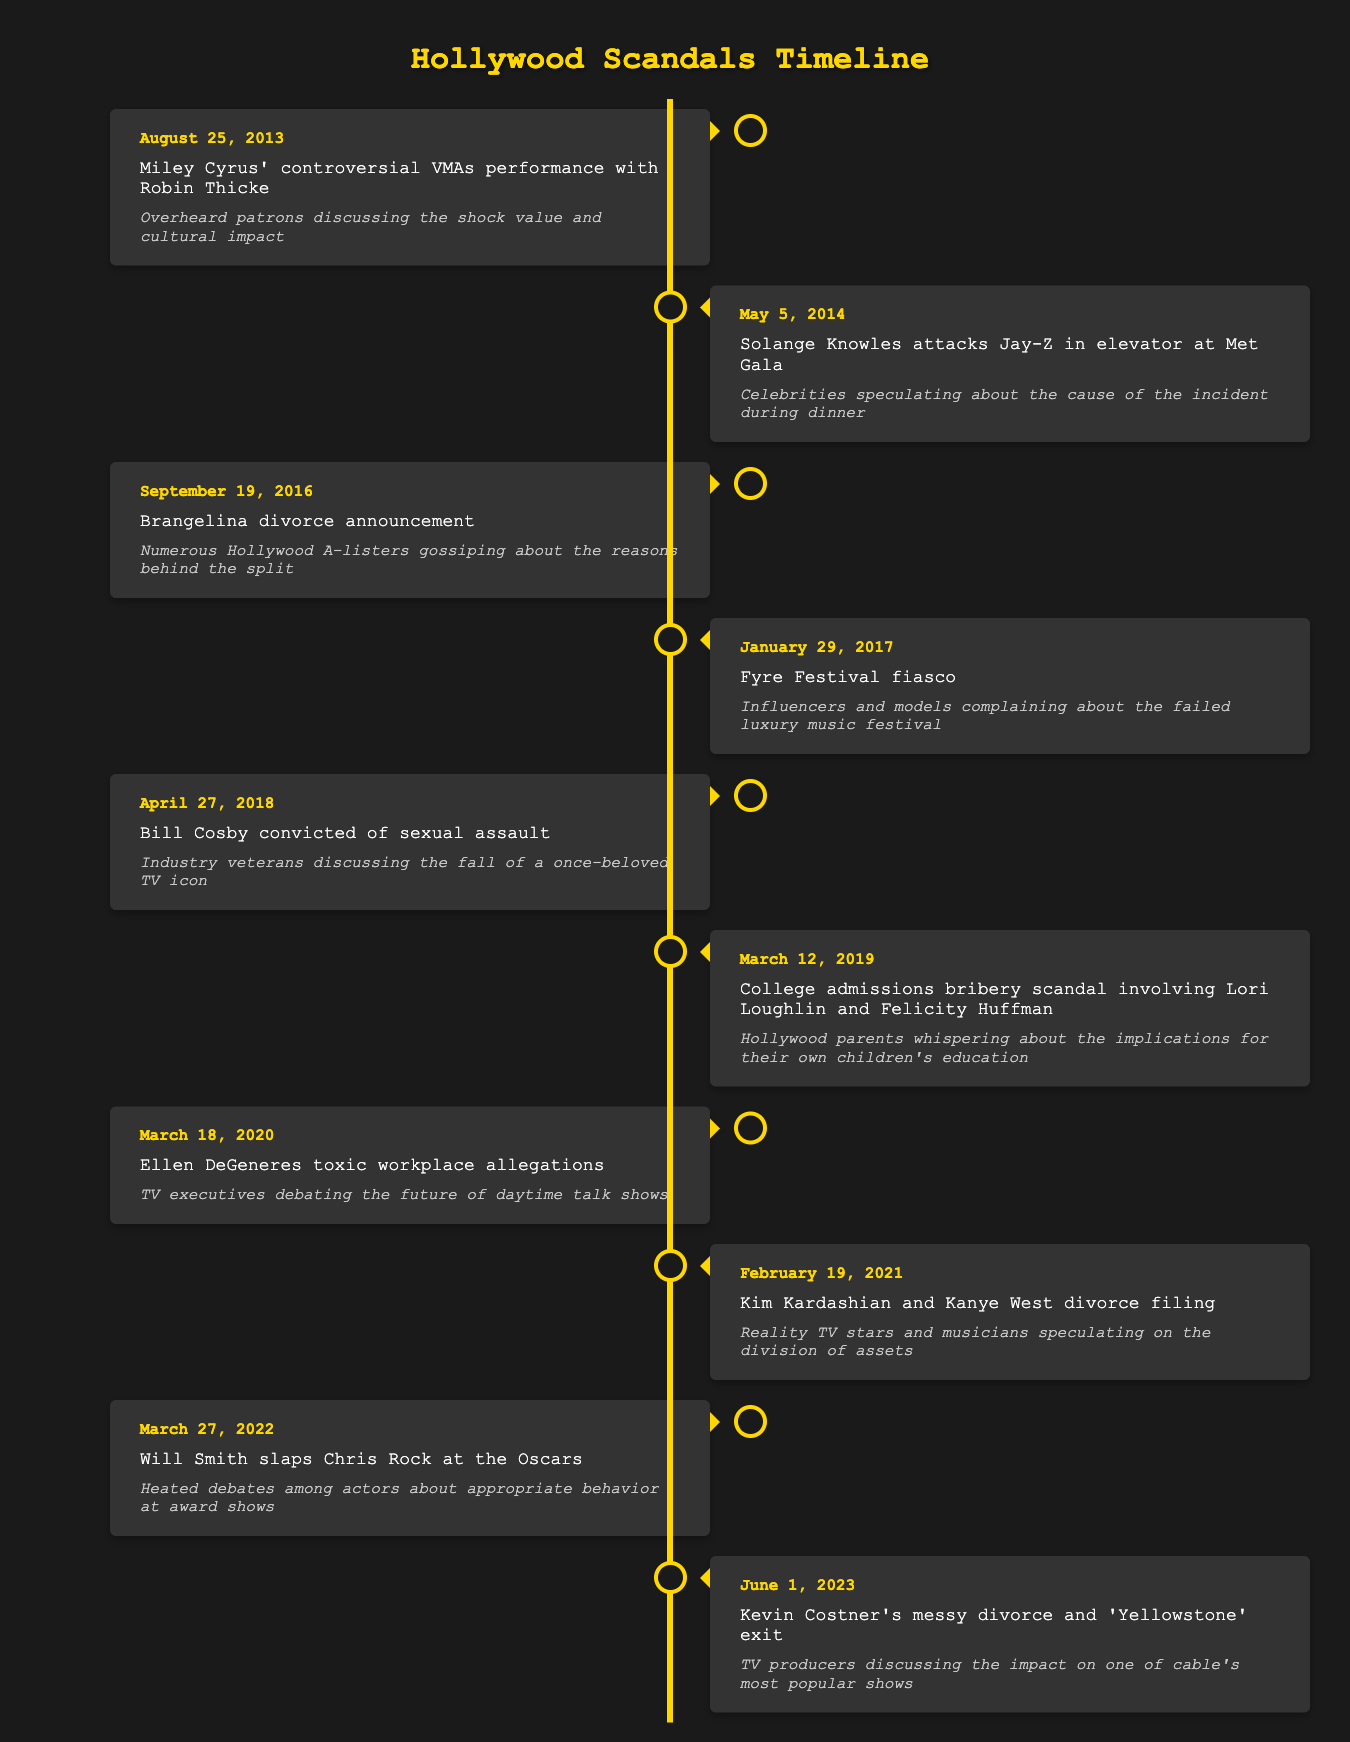What significant event occurred on August 25, 2013? The table indicates that on this date, Miley Cyrus had a controversial VMAs performance with Robin Thicke.
Answer: Miley Cyrus' controversial VMAs performance with Robin Thicke What was the date of the Brangelina divorce announcement? Looking at the timeline, the Brangelina divorce was announced on September 19, 2016.
Answer: September 19, 2016 Were any celebrity scandals reported in March? Yes, two notable scandals occurred in March; one in March 2019 regarding the college admissions bribery scandal and another in March 2020 with Ellen DeGeneres' toxic workplace allegations.
Answer: Yes Which event is associated with the date February 19, 2021? According to the timeline, this date corresponds to Kim Kardashian and Kanye West filing for divorce.
Answer: Kim Kardashian and Kanye West divorce filing In the provided timeline, how many events took place in 2018? Upon checking the timeline, there is only one event in 2018 related to Bill Cosby being convicted of sexual assault.
Answer: 1 event What comparison can be made between the events of 2014 and 2022? In 2014, the event involved Solange Knowles attacking Jay-Z at the Met Gala, and in 2022, Will Smith slapped Chris Rock at the Oscars. Both events were high-profile incidents at notable public appearances, highlighting controversies in award-related environments.
Answer: Both involved controversies at high-profile events What is the timeframe between Miley Cyrus' VMAs performance and the Fyre Festival fiasco? To determine the timeframe, we calculate the difference between August 25, 2013, and January 29, 2017, which is approximately 3 years and 5 months.
Answer: Approximately 3 years and 5 months Did the discussion around Bill Cosby's conviction involve younger celebrities? The details from the table indicate that industry veterans, not younger celebrities, were discussing the implications of Bill Cosby’s conviction.
Answer: No Was Ellen DeGeneres' toxic workplace scandal discussed in 2020? Yes, the timeline indicates that the allegations surfaced on March 18, 2020.
Answer: Yes 